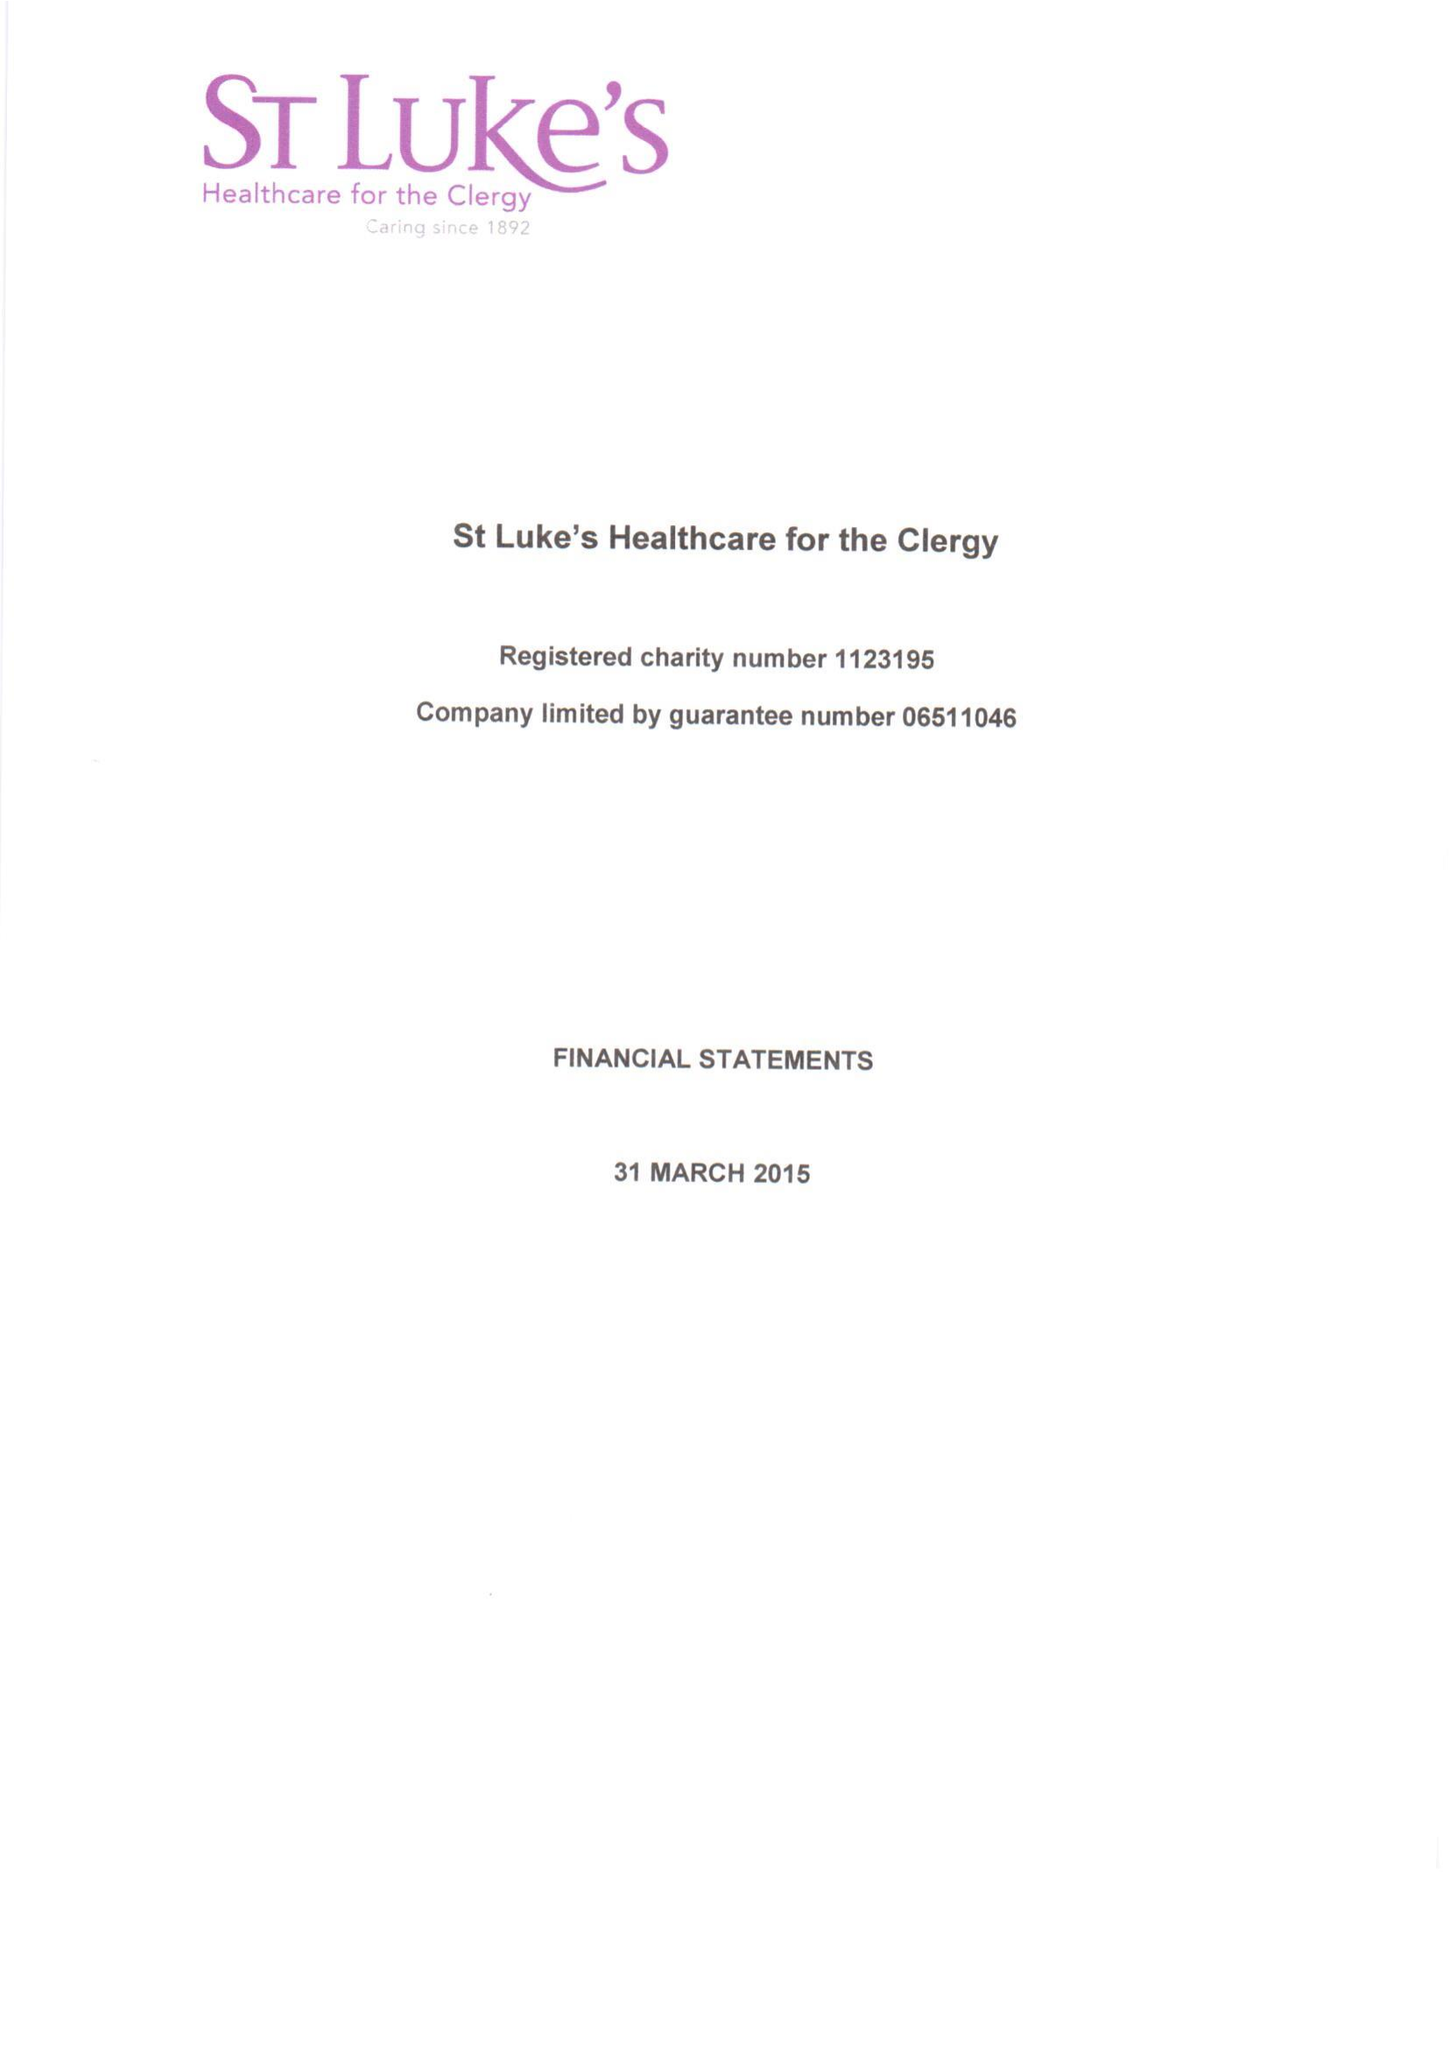What is the value for the address__postcode?
Answer the question using a single word or phrase. SW1P 3AZ 